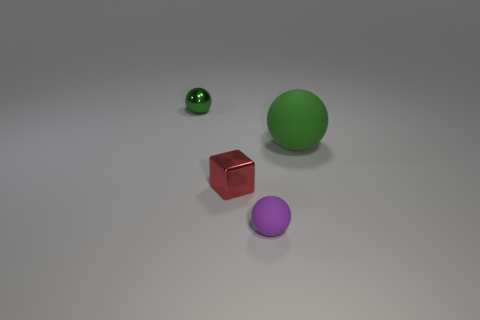Add 3 large matte spheres. How many objects exist? 7 Subtract all spheres. How many objects are left? 1 Add 1 spheres. How many spheres exist? 4 Subtract 0 cyan blocks. How many objects are left? 4 Subtract all big cyan shiny objects. Subtract all spheres. How many objects are left? 1 Add 3 small green objects. How many small green objects are left? 4 